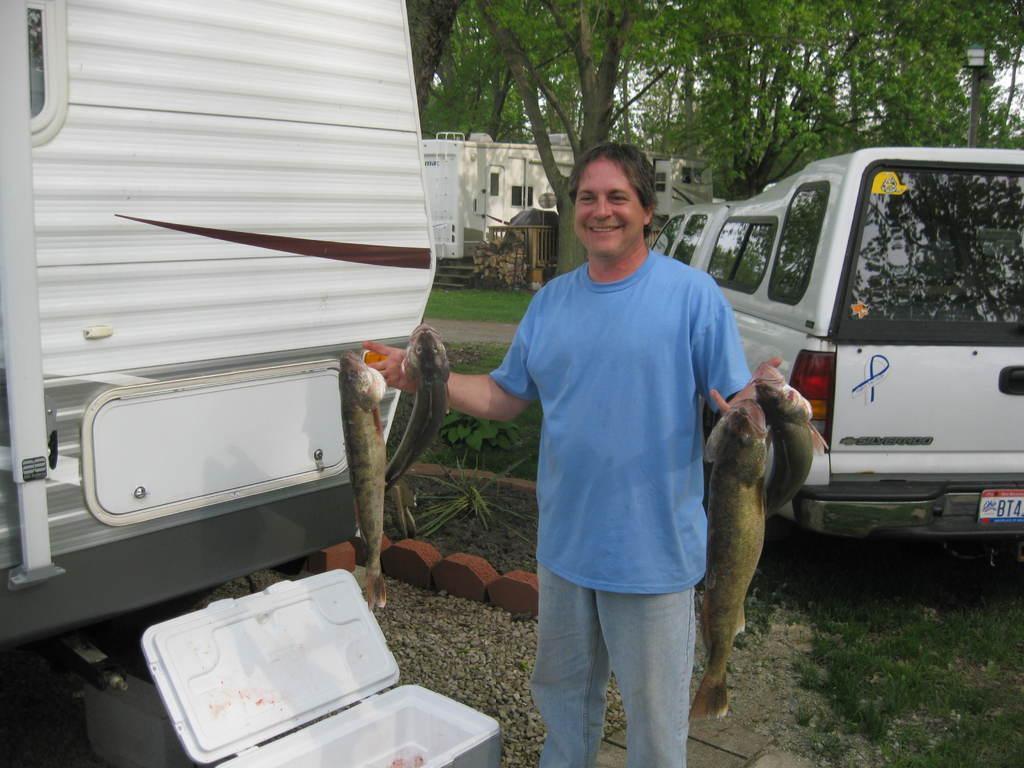Please provide a concise description of this image. In this image we can see a person standing and holding fish in his hands, we can also see some vehicles parked on the ground, some plants and a container placed on the ground. In the center of the image we can see the staircase and railing. On the right side of the image we can see light pole. At the top of the image we can see a group of trees. 